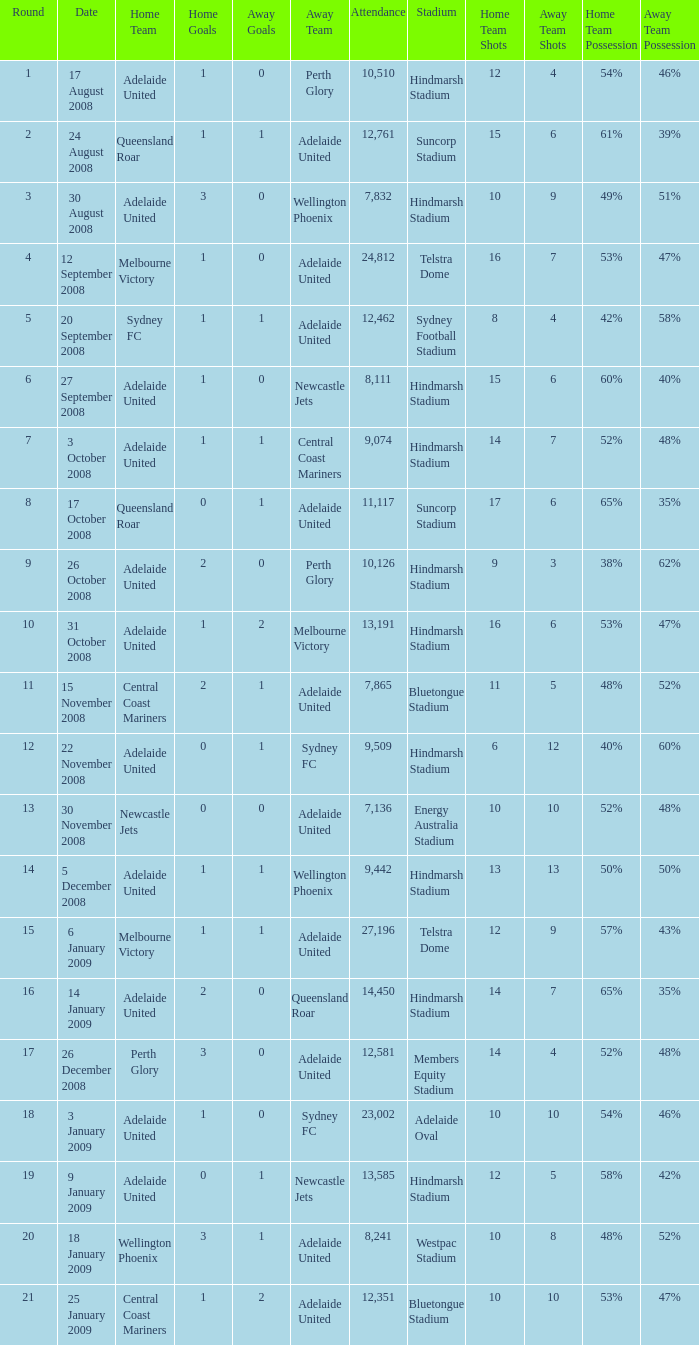Who was the away team when Queensland Roar was the home team in the round less than 3? Adelaide United. 